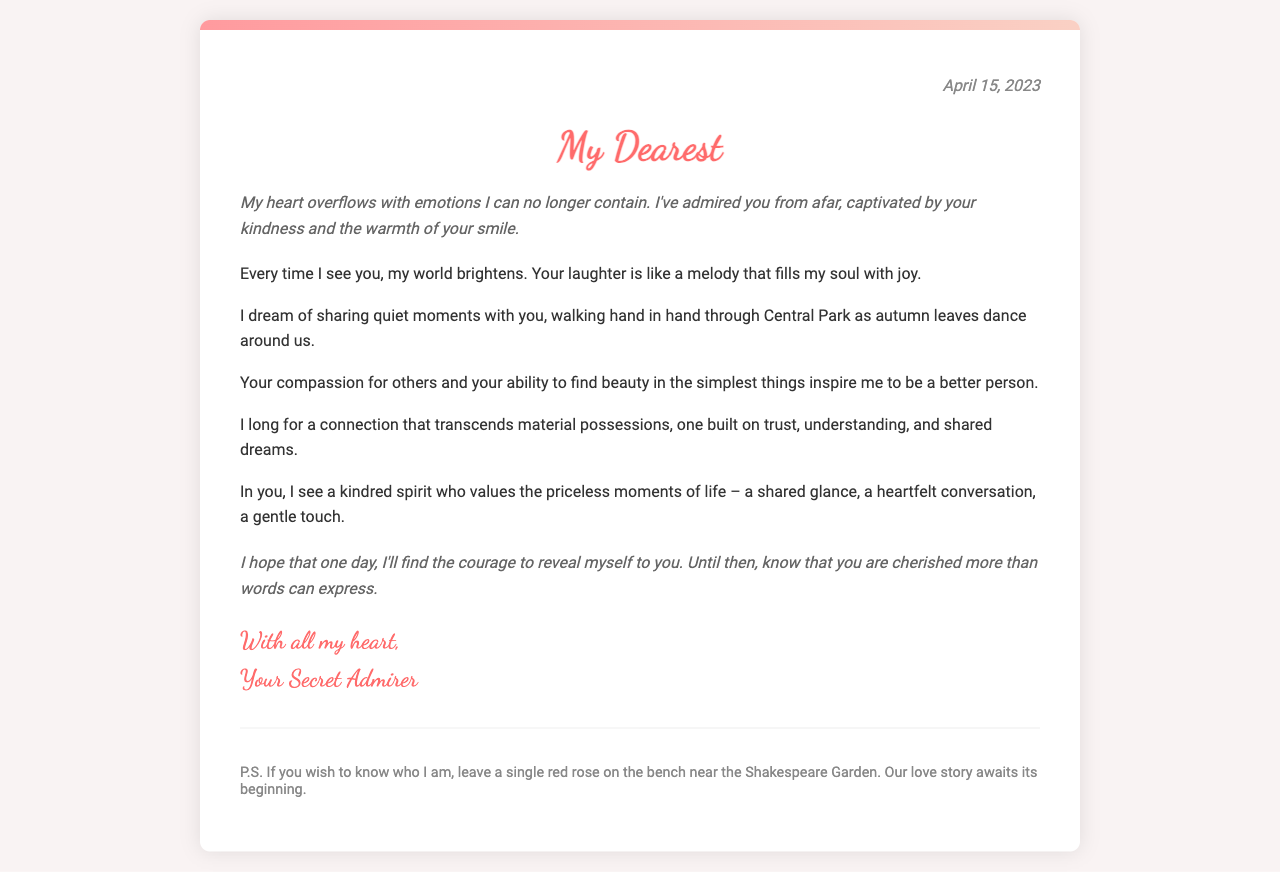What is the date of the letter? The date of the letter is mentioned at the top of the document in the header section.
Answer: April 15, 2023 Who is the letter addressed to? The salutation at the beginning of the letter indicates the recipient, though no specific name is used.
Answer: My Dearest What inspires the secret admirer? The letter expresses admiration for the recipient's qualities, which gives insight into what inspires the writer.
Answer: Compassion for others What does the admirer dream of sharing? The body text describes a specific activity that the admirer wishes to partake in with the recipient, implying closeness.
Answer: Quiet moments How does the letter describe laughter? The admirer uses a simile to express how they feel about the recipient's laughter.
Answer: A melody What does the admirer request in the P.S.? The closing remark in the footnote section contains a specific request related to identifying the admirer.
Answer: Leave a single red rose What kind of connection does the admirer long for? The letter outlines the nature of the relationship the admirer hopes to build, emphasizing key emotional elements.
Answer: Trust, understanding, and shared dreams What is the emotional tone of the letter? The overall language, choices of phrases, and expressions of affection point to the document's predominant emotional atmosphere.
Answer: Heartfelt 